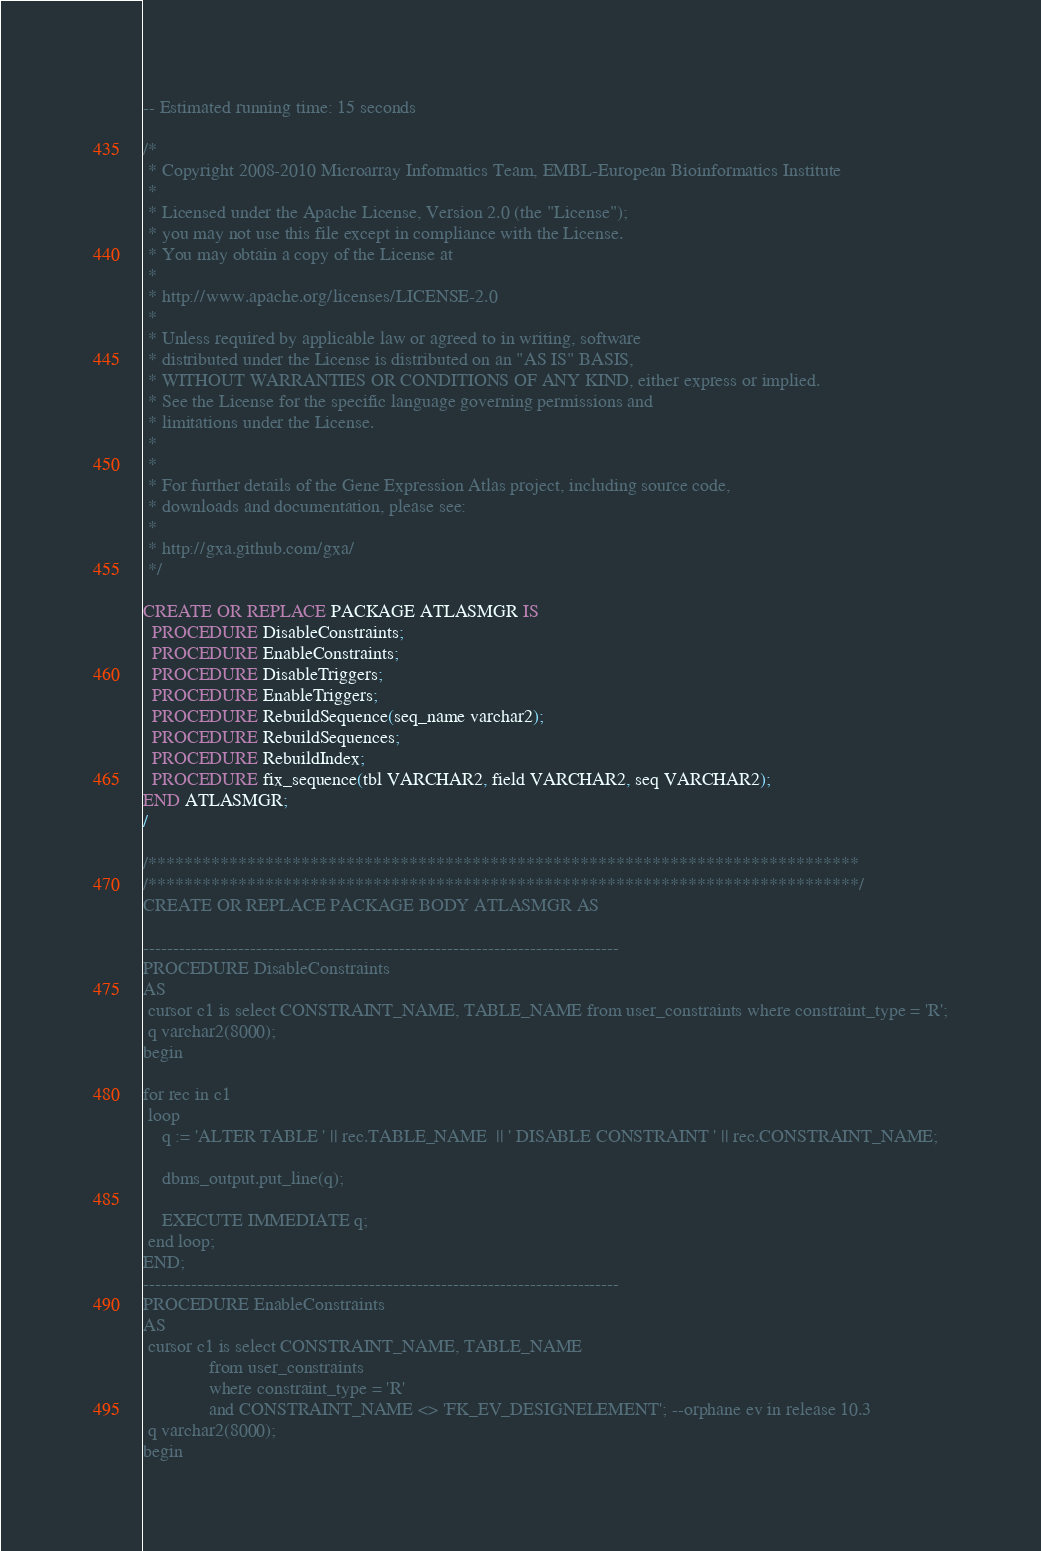Convert code to text. <code><loc_0><loc_0><loc_500><loc_500><_SQL_>-- Estimated running time: 15 seconds

/*
 * Copyright 2008-2010 Microarray Informatics Team, EMBL-European Bioinformatics Institute
 *
 * Licensed under the Apache License, Version 2.0 (the "License");
 * you may not use this file except in compliance with the License.
 * You may obtain a copy of the License at
 *
 * http://www.apache.org/licenses/LICENSE-2.0
 *
 * Unless required by applicable law or agreed to in writing, software
 * distributed under the License is distributed on an "AS IS" BASIS,
 * WITHOUT WARRANTIES OR CONDITIONS OF ANY KIND, either express or implied.
 * See the License for the specific language governing permissions and
 * limitations under the License.
 *
 *
 * For further details of the Gene Expression Atlas project, including source code,
 * downloads and documentation, please see:
 *
 * http://gxa.github.com/gxa/
 */

CREATE OR REPLACE PACKAGE ATLASMGR IS
  PROCEDURE DisableConstraints;
  PROCEDURE EnableConstraints;
  PROCEDURE DisableTriggers;
  PROCEDURE EnableTriggers;
  PROCEDURE RebuildSequence(seq_name varchar2);
  PROCEDURE RebuildSequences;
  PROCEDURE RebuildIndex;
  PROCEDURE fix_sequence(tbl VARCHAR2, field VARCHAR2, seq VARCHAR2);
END ATLASMGR;
/

/*******************************************************************************
/*******************************************************************************/
CREATE OR REPLACE PACKAGE BODY ATLASMGR AS

--------------------------------------------------------------------------------
PROCEDURE DisableConstraints
AS
 cursor c1 is select CONSTRAINT_NAME, TABLE_NAME from user_constraints where constraint_type = 'R';
 q varchar2(8000);
begin

for rec in c1
 loop
    q := 'ALTER TABLE ' || rec.TABLE_NAME  || ' DISABLE CONSTRAINT ' || rec.CONSTRAINT_NAME;

    dbms_output.put_line(q);

    EXECUTE IMMEDIATE q;
 end loop;
END;
--------------------------------------------------------------------------------
PROCEDURE EnableConstraints
AS
 cursor c1 is select CONSTRAINT_NAME, TABLE_NAME
              from user_constraints
              where constraint_type = 'R'
              and CONSTRAINT_NAME <> 'FK_EV_DESIGNELEMENT'; --orphane ev in release 10.3
 q varchar2(8000);
begin</code> 